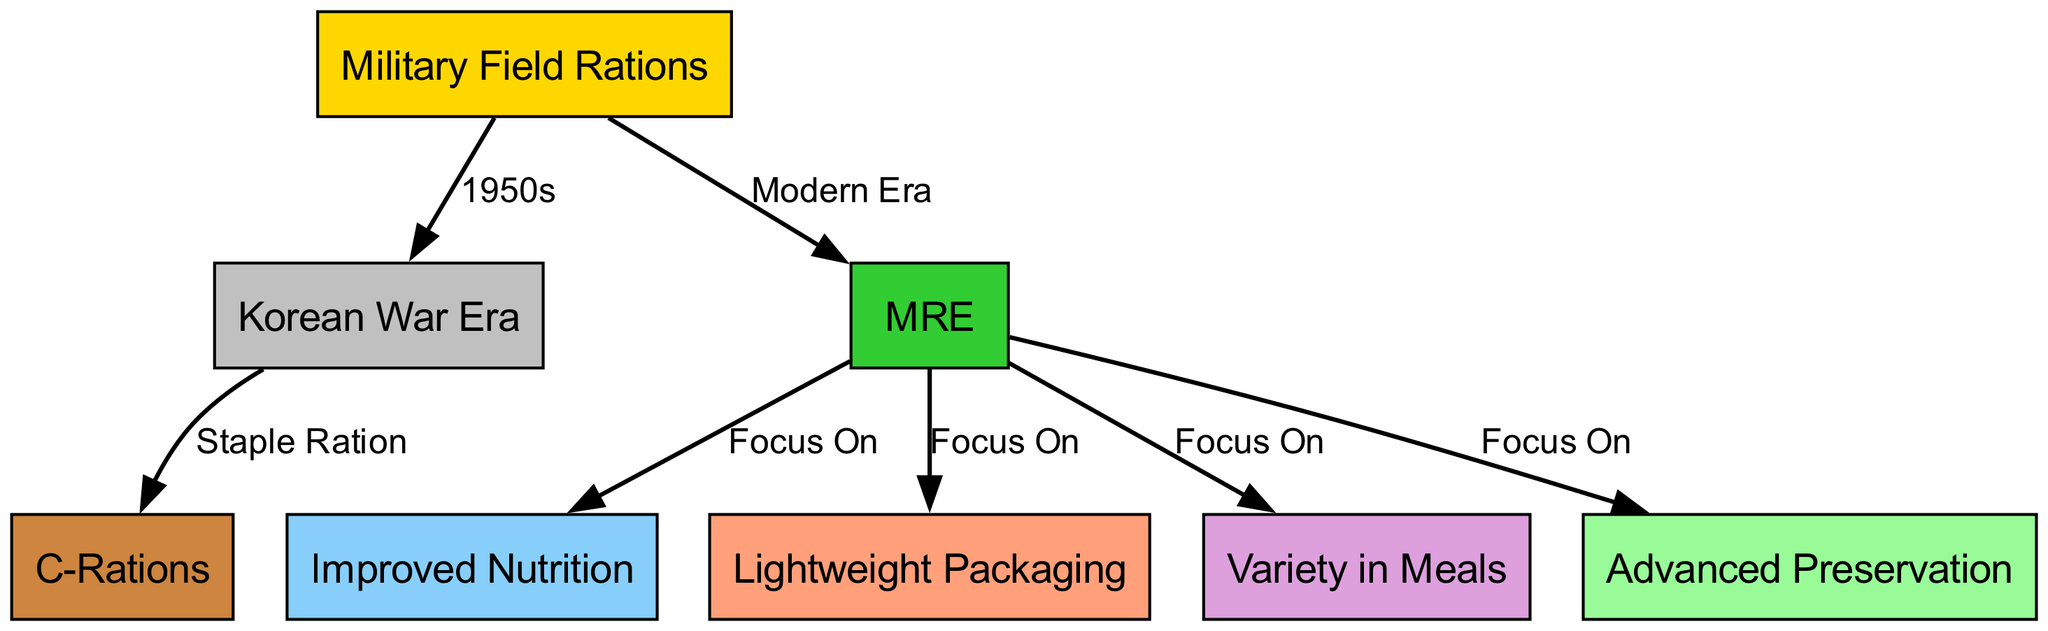What era is associated with Military Field Rations? The "field_rations" node connects directly to the "korean_war" node, indicating that Military Field Rations are associated with the Korean War era.
Answer: Korean War Era How many focus areas are listed under MRE? From the "mre" node, there are four outgoing edges leading to the focus areas of "nutrition," "lightweight," "variety," and "advanced preservation." Thus, the number of focus areas is counted from these connections.
Answer: 4 What type of ration was used during the Korean War? The diagram shows that the "korean_war" node points directly to the "c_rations" node, indicating that C-Rations were the staple ration during this period.
Answer: C-Rations Which aspect of modern military rations emphasizes lightweight alternatives? The "mre" node connects to the "lightweight" node, indicating that one of the focuses of modern military rations is lightweight packaging.
Answer: Lightweight Packaging What is the relationship between MRE and Improved Nutrition? The "mre" node has a direct edge pointing to the "nutrition" node, indicating that MREs have a focus on improved nutrition as part of their design and functionality.
Answer: Focus On How does advanced preservation relate to modern military rations? The "mre" node connects to the "advanced_preservation" node, which shows that modern military rations like MREs focus on advanced preservation methods to enhance shelf life and food safety.
Answer: Focus On What was the primary development of military field rations in the 1950s? The connection from the "korean_war" node to the "c_rations" node indicates that during the 1950s, the primary development of military field rations was the implementation of C-Rations.
Answer: C-Rations Which node indicates a variety of meals in modern rations? The diagram illustrates that the "mre" node has a direct edge to the "variety" node, highlighting that modern military rations emphasize a variety of meal options.
Answer: Variety in Meals 